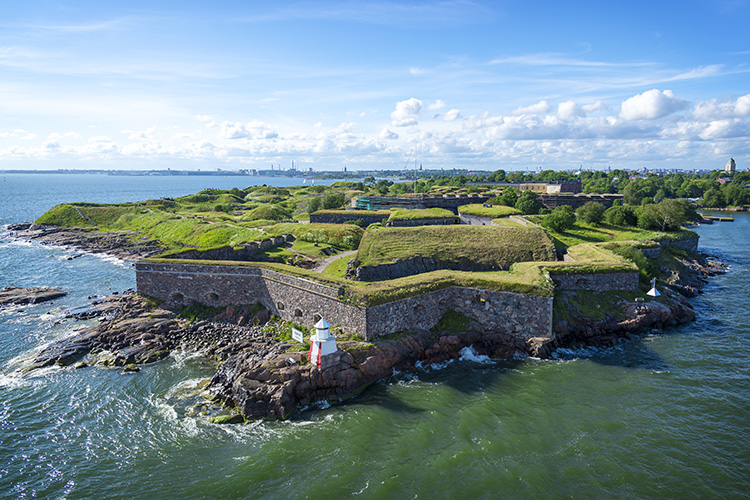Can you tell a story about the people who might have lived in this fortress centuries ago? Centuries ago, as the sun rose over Suomenlinna Fortress, the air buzzed with a mix of military discipline and domestic life. The fortress was home to soldiers, their families, and various tradespeople essential to the fortress’s function and defense. On a typical day, soldiers clad in their uniforms could be seen patrolling the walls and training in the courtyards, their disciplined movements a testament to their readiness.

Inside the walls, children played among the stone structures and grassy terrains while women busied themselves with daily chores – cooking, mending clothes, and fetching water. Blacksmiths hammered away in their forges, producing weapons and tools, while merchants traded goods brought in from distant lands by the ships docked nearby. The fortress was a bustling microcosm of society, where every individual played a crucial role in maintaining the order and efficiency needed to defend the territory.

Evenings were marked by community gatherings where stories of bravery and local legends were shared, fostering a sense of unity and resilience among the inhabitants. The fortress was not just a military stronghold but a vibrant community, living and thriving amid the backdrop of historical conflict and cooperation. 